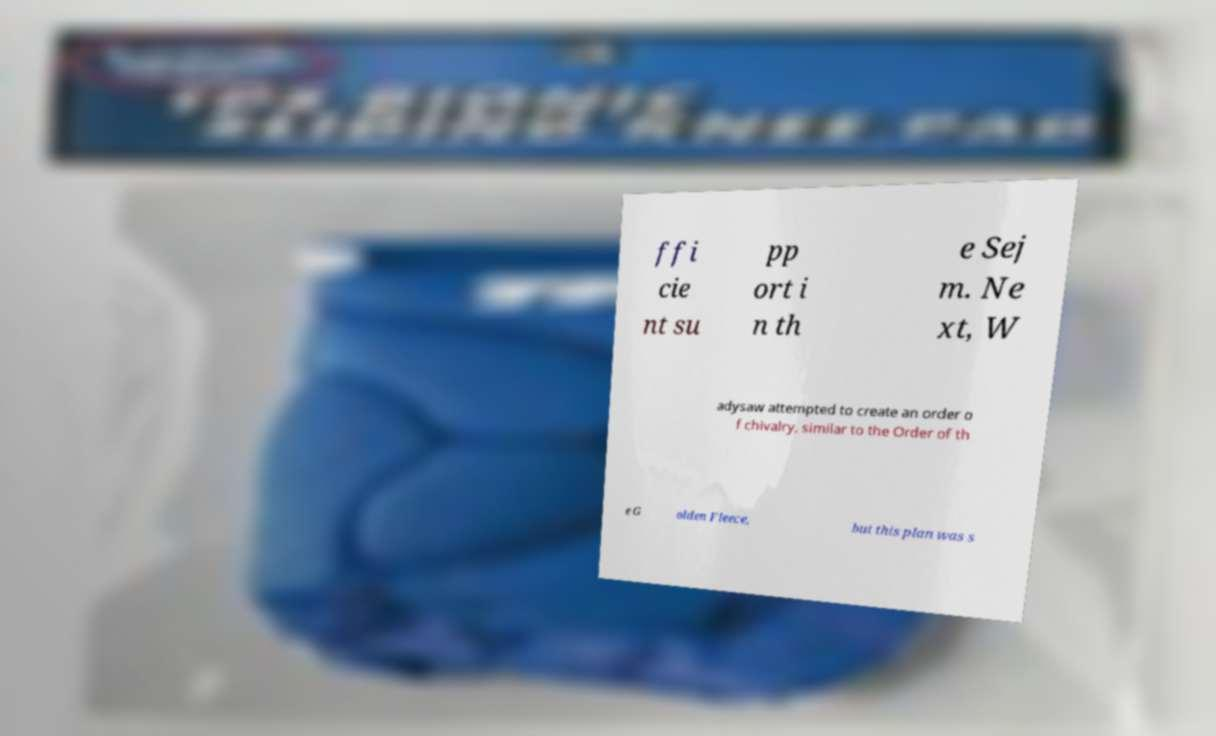What messages or text are displayed in this image? I need them in a readable, typed format. ffi cie nt su pp ort i n th e Sej m. Ne xt, W adysaw attempted to create an order o f chivalry, similar to the Order of th e G olden Fleece, but this plan was s 